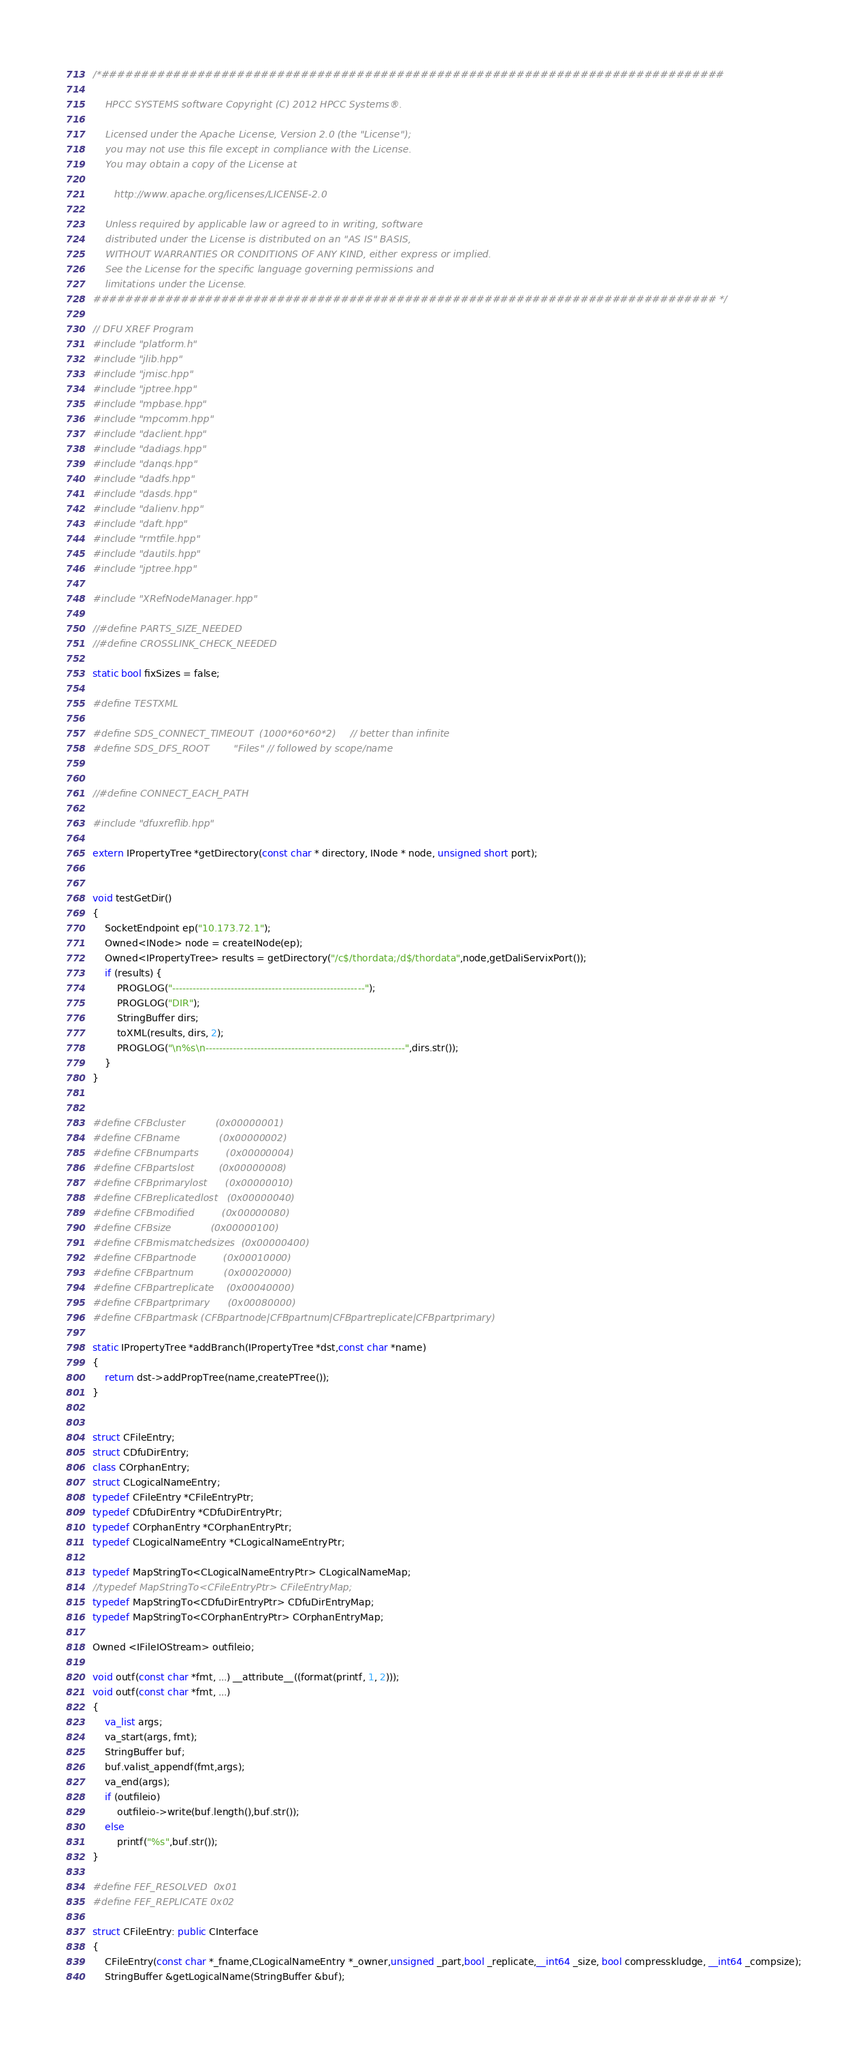<code> <loc_0><loc_0><loc_500><loc_500><_C++_>/*##############################################################################

    HPCC SYSTEMS software Copyright (C) 2012 HPCC Systems®.

    Licensed under the Apache License, Version 2.0 (the "License");
    you may not use this file except in compliance with the License.
    You may obtain a copy of the License at

       http://www.apache.org/licenses/LICENSE-2.0

    Unless required by applicable law or agreed to in writing, software
    distributed under the License is distributed on an "AS IS" BASIS,
    WITHOUT WARRANTIES OR CONDITIONS OF ANY KIND, either express or implied.
    See the License for the specific language governing permissions and
    limitations under the License.
############################################################################## */

// DFU XREF Program
#include "platform.h"
#include "jlib.hpp"
#include "jmisc.hpp"
#include "jptree.hpp"
#include "mpbase.hpp"
#include "mpcomm.hpp"
#include "daclient.hpp"
#include "dadiags.hpp"
#include "danqs.hpp"
#include "dadfs.hpp"
#include "dasds.hpp"
#include "dalienv.hpp"
#include "daft.hpp"
#include "rmtfile.hpp"
#include "dautils.hpp"
#include "jptree.hpp"

#include "XRefNodeManager.hpp"

//#define PARTS_SIZE_NEEDED
//#define CROSSLINK_CHECK_NEEDED

static bool fixSizes = false;

#define TESTXML

#define SDS_CONNECT_TIMEOUT  (1000*60*60*2)     // better than infinite
#define SDS_DFS_ROOT        "Files" // followed by scope/name


//#define CONNECT_EACH_PATH

#include "dfuxreflib.hpp"

extern IPropertyTree *getDirectory(const char * directory, INode * node, unsigned short port);


void testGetDir()
{
    SocketEndpoint ep("10.173.72.1");
    Owned<INode> node = createINode(ep);
    Owned<IPropertyTree> results = getDirectory("/c$/thordata;/d$/thordata",node,getDaliServixPort());
    if (results) {
        PROGLOG("--------------------------------------------------------");
        PROGLOG("DIR");
        StringBuffer dirs;
        toXML(results, dirs, 2);
        PROGLOG("\n%s\n----------------------------------------------------------",dirs.str());
    }
}


#define CFBcluster          (0x00000001)
#define CFBname             (0x00000002)
#define CFBnumparts         (0x00000004)
#define CFBpartslost        (0x00000008)
#define CFBprimarylost      (0x00000010)
#define CFBreplicatedlost   (0x00000040)
#define CFBmodified         (0x00000080)
#define CFBsize             (0x00000100)
#define CFBmismatchedsizes  (0x00000400)
#define CFBpartnode         (0x00010000)
#define CFBpartnum          (0x00020000)
#define CFBpartreplicate    (0x00040000)
#define CFBpartprimary      (0x00080000)
#define CFBpartmask (CFBpartnode|CFBpartnum|CFBpartreplicate|CFBpartprimary)

static IPropertyTree *addBranch(IPropertyTree *dst,const char *name)
{
    return dst->addPropTree(name,createPTree());
}


struct CFileEntry;
struct CDfuDirEntry;
class COrphanEntry;
struct CLogicalNameEntry;
typedef CFileEntry *CFileEntryPtr;
typedef CDfuDirEntry *CDfuDirEntryPtr;
typedef COrphanEntry *COrphanEntryPtr;
typedef CLogicalNameEntry *CLogicalNameEntryPtr;

typedef MapStringTo<CLogicalNameEntryPtr> CLogicalNameMap;
//typedef MapStringTo<CFileEntryPtr> CFileEntryMap;
typedef MapStringTo<CDfuDirEntryPtr> CDfuDirEntryMap;
typedef MapStringTo<COrphanEntryPtr> COrphanEntryMap;

Owned <IFileIOStream> outfileio;

void outf(const char *fmt, ...) __attribute__((format(printf, 1, 2)));
void outf(const char *fmt, ...) 
{
    va_list args;
    va_start(args, fmt);
    StringBuffer buf;
    buf.valist_appendf(fmt,args);
    va_end(args);
    if (outfileio)
        outfileio->write(buf.length(),buf.str());
    else
        printf("%s",buf.str());
}

#define FEF_RESOLVED  0x01
#define FEF_REPLICATE 0x02

struct CFileEntry: public CInterface
{
    CFileEntry(const char *_fname,CLogicalNameEntry *_owner,unsigned _part,bool _replicate,__int64 _size, bool compresskludge, __int64 _compsize);
    StringBuffer &getLogicalName(StringBuffer &buf);
</code> 